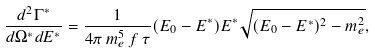Convert formula to latex. <formula><loc_0><loc_0><loc_500><loc_500>\frac { d ^ { 2 } \Gamma ^ { * } } { d \Omega ^ { * } d E ^ { * } } = \frac { 1 } { 4 \pi \, m _ { e } ^ { 5 } \, f \, \tau } ( E _ { 0 } - E ^ { * } ) E ^ { * } \sqrt { ( E _ { 0 } - E ^ { * } ) ^ { 2 } - m _ { e } ^ { 2 } } ,</formula> 